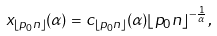Convert formula to latex. <formula><loc_0><loc_0><loc_500><loc_500>x _ { \lfloor { p _ { 0 } n } \rfloor } ( \alpha ) = c _ { \lfloor { p _ { 0 } n } \rfloor } ( \alpha ) { \lfloor { p _ { 0 } n } \rfloor } ^ { - \frac { 1 } { \alpha } } ,</formula> 